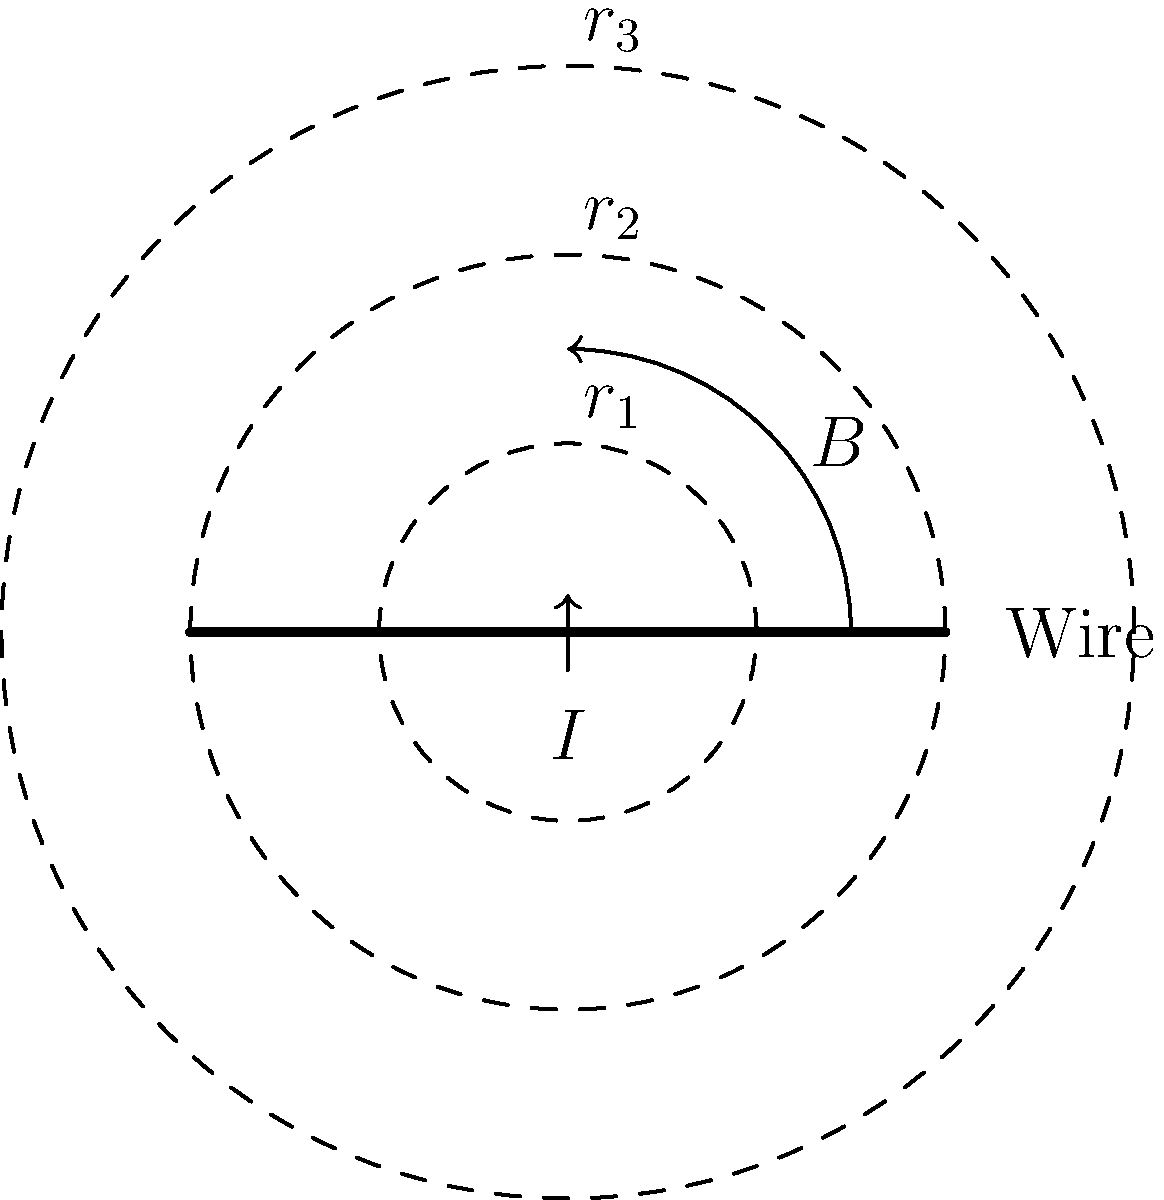Despite your skepticism towards local customs, you're tasked with determining the magnetic field strength around a current-carrying wire. Given that the magnetic field $B$ at a distance $r$ from a long, straight wire carrying current $I$ is given by $B = \frac{\mu_0 I}{2\pi r}$, where $\mu_0$ is the permeability of free space, how does the field strength change as you move from $r_1$ to $r_2$ to $r_3$? Let's approach this systematically:

1) The magnetic field strength $B$ is given by the equation:
   $B = \frac{\mu_0 I}{2\pi r}$

2) We can see that $B$ is inversely proportional to $r$, as all other terms ($\mu_0$, $I$, and $2\pi$) are constants.

3) This means that as $r$ increases, $B$ decreases.

4) In the diagram, we see three concentric circles with radii $r_1$, $r_2$, and $r_3$, where $r_1 < r_2 < r_3$.

5) As we move from $r_1$ to $r_2$ to $r_3$, we are increasing the distance from the wire.

6) Therefore, the magnetic field strength will decrease as we move outward.

7) Specifically, if we double the distance (e.g., from $r_1$ to $2r_1$), the field strength will halve.

8) This relationship can be expressed mathematically as:
   $B_2 = B_1 \cdot \frac{r_1}{r_2}$

Despite any local superstitions, this is a scientifically proven relationship that holds true regardless of cultural beliefs.
Answer: The magnetic field strength decreases as distance from the wire increases. 